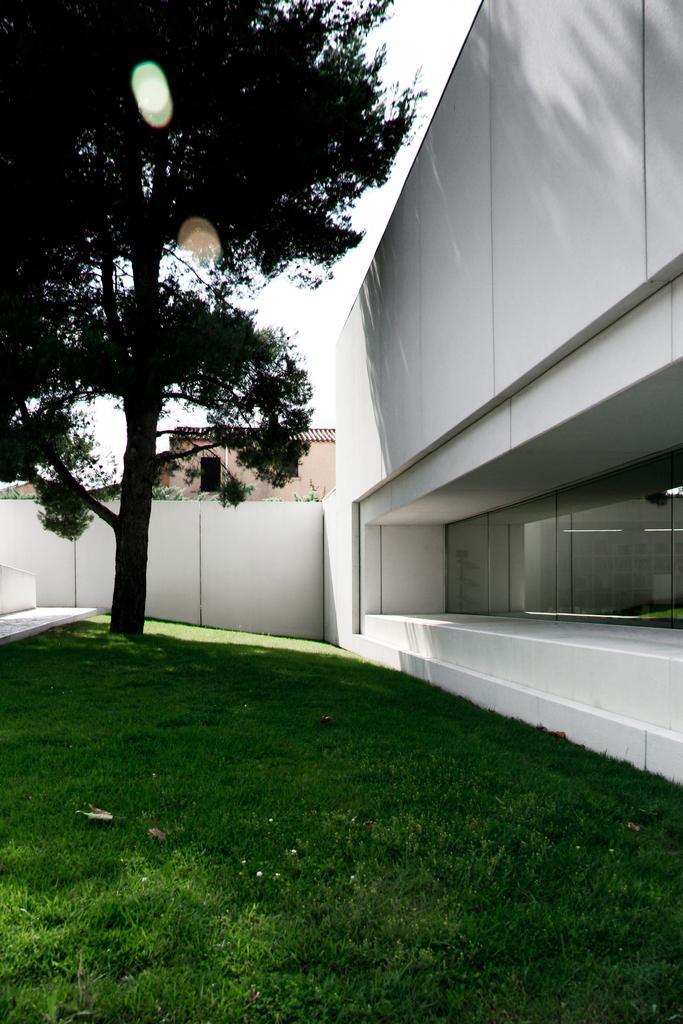Please provide a concise description of this image. In this image I can see grass and a white building on the left. There is a tree, wall and building at the back. There is sky at the top. 